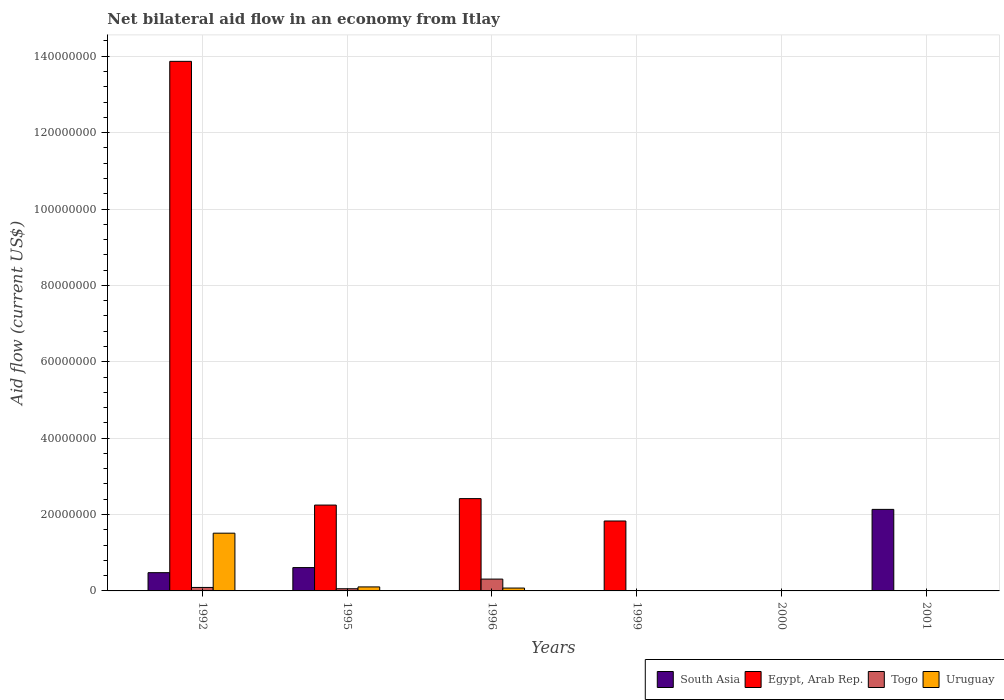Are the number of bars on each tick of the X-axis equal?
Give a very brief answer. No. How many bars are there on the 4th tick from the right?
Your response must be concise. 3. What is the label of the 3rd group of bars from the left?
Give a very brief answer. 1996. In how many cases, is the number of bars for a given year not equal to the number of legend labels?
Provide a short and direct response. 4. What is the net bilateral aid flow in Uruguay in 1992?
Provide a short and direct response. 1.51e+07. Across all years, what is the maximum net bilateral aid flow in Uruguay?
Offer a terse response. 1.51e+07. What is the total net bilateral aid flow in South Asia in the graph?
Provide a succinct answer. 3.22e+07. What is the difference between the net bilateral aid flow in Togo in 1996 and that in 2001?
Your answer should be compact. 3.02e+06. What is the difference between the net bilateral aid flow in Togo in 2000 and the net bilateral aid flow in South Asia in 1999?
Your answer should be compact. 10000. What is the average net bilateral aid flow in Uruguay per year?
Provide a short and direct response. 2.82e+06. In the year 1992, what is the difference between the net bilateral aid flow in Uruguay and net bilateral aid flow in Togo?
Your answer should be very brief. 1.42e+07. What is the ratio of the net bilateral aid flow in Uruguay in 1992 to that in 1996?
Keep it short and to the point. 20.16. Is the net bilateral aid flow in Togo in 1992 less than that in 2001?
Keep it short and to the point. No. What is the difference between the highest and the second highest net bilateral aid flow in Togo?
Your answer should be very brief. 2.19e+06. What is the difference between the highest and the lowest net bilateral aid flow in Egypt, Arab Rep.?
Make the answer very short. 1.39e+08. Is the sum of the net bilateral aid flow in Togo in 1995 and 1999 greater than the maximum net bilateral aid flow in Egypt, Arab Rep. across all years?
Provide a succinct answer. No. Are all the bars in the graph horizontal?
Provide a short and direct response. No. How many years are there in the graph?
Your answer should be very brief. 6. How many legend labels are there?
Make the answer very short. 4. How are the legend labels stacked?
Your answer should be compact. Horizontal. What is the title of the graph?
Provide a short and direct response. Net bilateral aid flow in an economy from Itlay. What is the label or title of the Y-axis?
Offer a terse response. Aid flow (current US$). What is the Aid flow (current US$) of South Asia in 1992?
Your answer should be compact. 4.78e+06. What is the Aid flow (current US$) of Egypt, Arab Rep. in 1992?
Provide a succinct answer. 1.39e+08. What is the Aid flow (current US$) in Togo in 1992?
Provide a succinct answer. 9.10e+05. What is the Aid flow (current US$) in Uruguay in 1992?
Make the answer very short. 1.51e+07. What is the Aid flow (current US$) in South Asia in 1995?
Provide a short and direct response. 6.11e+06. What is the Aid flow (current US$) of Egypt, Arab Rep. in 1995?
Offer a terse response. 2.25e+07. What is the Aid flow (current US$) in Togo in 1995?
Keep it short and to the point. 5.70e+05. What is the Aid flow (current US$) of Uruguay in 1995?
Make the answer very short. 1.05e+06. What is the Aid flow (current US$) in South Asia in 1996?
Provide a succinct answer. 0. What is the Aid flow (current US$) of Egypt, Arab Rep. in 1996?
Keep it short and to the point. 2.42e+07. What is the Aid flow (current US$) in Togo in 1996?
Ensure brevity in your answer.  3.10e+06. What is the Aid flow (current US$) in Uruguay in 1996?
Ensure brevity in your answer.  7.50e+05. What is the Aid flow (current US$) in South Asia in 1999?
Your answer should be very brief. 0. What is the Aid flow (current US$) in Egypt, Arab Rep. in 1999?
Ensure brevity in your answer.  1.83e+07. What is the Aid flow (current US$) in South Asia in 2000?
Keep it short and to the point. 0. What is the Aid flow (current US$) of Egypt, Arab Rep. in 2000?
Make the answer very short. 0. What is the Aid flow (current US$) of Togo in 2000?
Make the answer very short. 10000. What is the Aid flow (current US$) in Uruguay in 2000?
Provide a succinct answer. 0. What is the Aid flow (current US$) of South Asia in 2001?
Your response must be concise. 2.14e+07. What is the Aid flow (current US$) of Togo in 2001?
Your response must be concise. 8.00e+04. What is the Aid flow (current US$) of Uruguay in 2001?
Give a very brief answer. 0. Across all years, what is the maximum Aid flow (current US$) of South Asia?
Make the answer very short. 2.14e+07. Across all years, what is the maximum Aid flow (current US$) of Egypt, Arab Rep.?
Make the answer very short. 1.39e+08. Across all years, what is the maximum Aid flow (current US$) of Togo?
Offer a very short reply. 3.10e+06. Across all years, what is the maximum Aid flow (current US$) in Uruguay?
Make the answer very short. 1.51e+07. Across all years, what is the minimum Aid flow (current US$) of Egypt, Arab Rep.?
Give a very brief answer. 0. Across all years, what is the minimum Aid flow (current US$) of Togo?
Keep it short and to the point. 10000. Across all years, what is the minimum Aid flow (current US$) of Uruguay?
Your answer should be very brief. 0. What is the total Aid flow (current US$) in South Asia in the graph?
Your answer should be very brief. 3.22e+07. What is the total Aid flow (current US$) of Egypt, Arab Rep. in the graph?
Provide a short and direct response. 2.04e+08. What is the total Aid flow (current US$) of Togo in the graph?
Make the answer very short. 4.68e+06. What is the total Aid flow (current US$) of Uruguay in the graph?
Your answer should be compact. 1.69e+07. What is the difference between the Aid flow (current US$) in South Asia in 1992 and that in 1995?
Your answer should be compact. -1.33e+06. What is the difference between the Aid flow (current US$) in Egypt, Arab Rep. in 1992 and that in 1995?
Your answer should be compact. 1.16e+08. What is the difference between the Aid flow (current US$) in Uruguay in 1992 and that in 1995?
Give a very brief answer. 1.41e+07. What is the difference between the Aid flow (current US$) of Egypt, Arab Rep. in 1992 and that in 1996?
Ensure brevity in your answer.  1.14e+08. What is the difference between the Aid flow (current US$) in Togo in 1992 and that in 1996?
Your response must be concise. -2.19e+06. What is the difference between the Aid flow (current US$) in Uruguay in 1992 and that in 1996?
Offer a terse response. 1.44e+07. What is the difference between the Aid flow (current US$) in Egypt, Arab Rep. in 1992 and that in 1999?
Keep it short and to the point. 1.20e+08. What is the difference between the Aid flow (current US$) of Togo in 1992 and that in 2000?
Offer a terse response. 9.00e+05. What is the difference between the Aid flow (current US$) in South Asia in 1992 and that in 2001?
Your answer should be very brief. -1.66e+07. What is the difference between the Aid flow (current US$) of Togo in 1992 and that in 2001?
Provide a short and direct response. 8.30e+05. What is the difference between the Aid flow (current US$) in Egypt, Arab Rep. in 1995 and that in 1996?
Your response must be concise. -1.69e+06. What is the difference between the Aid flow (current US$) of Togo in 1995 and that in 1996?
Your answer should be compact. -2.53e+06. What is the difference between the Aid flow (current US$) in Egypt, Arab Rep. in 1995 and that in 1999?
Ensure brevity in your answer.  4.17e+06. What is the difference between the Aid flow (current US$) in Togo in 1995 and that in 1999?
Your response must be concise. 5.60e+05. What is the difference between the Aid flow (current US$) in Togo in 1995 and that in 2000?
Offer a terse response. 5.60e+05. What is the difference between the Aid flow (current US$) of South Asia in 1995 and that in 2001?
Keep it short and to the point. -1.52e+07. What is the difference between the Aid flow (current US$) in Egypt, Arab Rep. in 1996 and that in 1999?
Keep it short and to the point. 5.86e+06. What is the difference between the Aid flow (current US$) of Togo in 1996 and that in 1999?
Your response must be concise. 3.09e+06. What is the difference between the Aid flow (current US$) of Togo in 1996 and that in 2000?
Give a very brief answer. 3.09e+06. What is the difference between the Aid flow (current US$) of Togo in 1996 and that in 2001?
Provide a succinct answer. 3.02e+06. What is the difference between the Aid flow (current US$) in Togo in 1999 and that in 2000?
Provide a short and direct response. 0. What is the difference between the Aid flow (current US$) of Togo in 2000 and that in 2001?
Your answer should be compact. -7.00e+04. What is the difference between the Aid flow (current US$) in South Asia in 1992 and the Aid flow (current US$) in Egypt, Arab Rep. in 1995?
Provide a succinct answer. -1.77e+07. What is the difference between the Aid flow (current US$) of South Asia in 1992 and the Aid flow (current US$) of Togo in 1995?
Keep it short and to the point. 4.21e+06. What is the difference between the Aid flow (current US$) in South Asia in 1992 and the Aid flow (current US$) in Uruguay in 1995?
Ensure brevity in your answer.  3.73e+06. What is the difference between the Aid flow (current US$) in Egypt, Arab Rep. in 1992 and the Aid flow (current US$) in Togo in 1995?
Offer a very short reply. 1.38e+08. What is the difference between the Aid flow (current US$) in Egypt, Arab Rep. in 1992 and the Aid flow (current US$) in Uruguay in 1995?
Offer a very short reply. 1.38e+08. What is the difference between the Aid flow (current US$) in Togo in 1992 and the Aid flow (current US$) in Uruguay in 1995?
Provide a short and direct response. -1.40e+05. What is the difference between the Aid flow (current US$) of South Asia in 1992 and the Aid flow (current US$) of Egypt, Arab Rep. in 1996?
Provide a short and direct response. -1.94e+07. What is the difference between the Aid flow (current US$) in South Asia in 1992 and the Aid flow (current US$) in Togo in 1996?
Your answer should be very brief. 1.68e+06. What is the difference between the Aid flow (current US$) in South Asia in 1992 and the Aid flow (current US$) in Uruguay in 1996?
Ensure brevity in your answer.  4.03e+06. What is the difference between the Aid flow (current US$) in Egypt, Arab Rep. in 1992 and the Aid flow (current US$) in Togo in 1996?
Make the answer very short. 1.36e+08. What is the difference between the Aid flow (current US$) in Egypt, Arab Rep. in 1992 and the Aid flow (current US$) in Uruguay in 1996?
Provide a short and direct response. 1.38e+08. What is the difference between the Aid flow (current US$) in South Asia in 1992 and the Aid flow (current US$) in Egypt, Arab Rep. in 1999?
Give a very brief answer. -1.35e+07. What is the difference between the Aid flow (current US$) in South Asia in 1992 and the Aid flow (current US$) in Togo in 1999?
Offer a terse response. 4.77e+06. What is the difference between the Aid flow (current US$) of Egypt, Arab Rep. in 1992 and the Aid flow (current US$) of Togo in 1999?
Ensure brevity in your answer.  1.39e+08. What is the difference between the Aid flow (current US$) in South Asia in 1992 and the Aid flow (current US$) in Togo in 2000?
Keep it short and to the point. 4.77e+06. What is the difference between the Aid flow (current US$) in Egypt, Arab Rep. in 1992 and the Aid flow (current US$) in Togo in 2000?
Provide a short and direct response. 1.39e+08. What is the difference between the Aid flow (current US$) in South Asia in 1992 and the Aid flow (current US$) in Togo in 2001?
Your answer should be very brief. 4.70e+06. What is the difference between the Aid flow (current US$) of Egypt, Arab Rep. in 1992 and the Aid flow (current US$) of Togo in 2001?
Provide a short and direct response. 1.39e+08. What is the difference between the Aid flow (current US$) in South Asia in 1995 and the Aid flow (current US$) in Egypt, Arab Rep. in 1996?
Provide a short and direct response. -1.81e+07. What is the difference between the Aid flow (current US$) in South Asia in 1995 and the Aid flow (current US$) in Togo in 1996?
Provide a short and direct response. 3.01e+06. What is the difference between the Aid flow (current US$) in South Asia in 1995 and the Aid flow (current US$) in Uruguay in 1996?
Ensure brevity in your answer.  5.36e+06. What is the difference between the Aid flow (current US$) of Egypt, Arab Rep. in 1995 and the Aid flow (current US$) of Togo in 1996?
Provide a succinct answer. 1.94e+07. What is the difference between the Aid flow (current US$) of Egypt, Arab Rep. in 1995 and the Aid flow (current US$) of Uruguay in 1996?
Provide a succinct answer. 2.17e+07. What is the difference between the Aid flow (current US$) of Togo in 1995 and the Aid flow (current US$) of Uruguay in 1996?
Make the answer very short. -1.80e+05. What is the difference between the Aid flow (current US$) in South Asia in 1995 and the Aid flow (current US$) in Egypt, Arab Rep. in 1999?
Provide a short and direct response. -1.22e+07. What is the difference between the Aid flow (current US$) of South Asia in 1995 and the Aid flow (current US$) of Togo in 1999?
Offer a very short reply. 6.10e+06. What is the difference between the Aid flow (current US$) of Egypt, Arab Rep. in 1995 and the Aid flow (current US$) of Togo in 1999?
Your answer should be very brief. 2.25e+07. What is the difference between the Aid flow (current US$) in South Asia in 1995 and the Aid flow (current US$) in Togo in 2000?
Keep it short and to the point. 6.10e+06. What is the difference between the Aid flow (current US$) in Egypt, Arab Rep. in 1995 and the Aid flow (current US$) in Togo in 2000?
Ensure brevity in your answer.  2.25e+07. What is the difference between the Aid flow (current US$) in South Asia in 1995 and the Aid flow (current US$) in Togo in 2001?
Your answer should be compact. 6.03e+06. What is the difference between the Aid flow (current US$) in Egypt, Arab Rep. in 1995 and the Aid flow (current US$) in Togo in 2001?
Offer a very short reply. 2.24e+07. What is the difference between the Aid flow (current US$) of Egypt, Arab Rep. in 1996 and the Aid flow (current US$) of Togo in 1999?
Your answer should be compact. 2.42e+07. What is the difference between the Aid flow (current US$) of Egypt, Arab Rep. in 1996 and the Aid flow (current US$) of Togo in 2000?
Ensure brevity in your answer.  2.42e+07. What is the difference between the Aid flow (current US$) in Egypt, Arab Rep. in 1996 and the Aid flow (current US$) in Togo in 2001?
Keep it short and to the point. 2.41e+07. What is the difference between the Aid flow (current US$) of Egypt, Arab Rep. in 1999 and the Aid flow (current US$) of Togo in 2000?
Your answer should be compact. 1.83e+07. What is the difference between the Aid flow (current US$) of Egypt, Arab Rep. in 1999 and the Aid flow (current US$) of Togo in 2001?
Your answer should be very brief. 1.82e+07. What is the average Aid flow (current US$) in South Asia per year?
Keep it short and to the point. 5.37e+06. What is the average Aid flow (current US$) of Egypt, Arab Rep. per year?
Make the answer very short. 3.39e+07. What is the average Aid flow (current US$) in Togo per year?
Give a very brief answer. 7.80e+05. What is the average Aid flow (current US$) of Uruguay per year?
Make the answer very short. 2.82e+06. In the year 1992, what is the difference between the Aid flow (current US$) of South Asia and Aid flow (current US$) of Egypt, Arab Rep.?
Offer a terse response. -1.34e+08. In the year 1992, what is the difference between the Aid flow (current US$) of South Asia and Aid flow (current US$) of Togo?
Offer a terse response. 3.87e+06. In the year 1992, what is the difference between the Aid flow (current US$) in South Asia and Aid flow (current US$) in Uruguay?
Offer a very short reply. -1.03e+07. In the year 1992, what is the difference between the Aid flow (current US$) in Egypt, Arab Rep. and Aid flow (current US$) in Togo?
Keep it short and to the point. 1.38e+08. In the year 1992, what is the difference between the Aid flow (current US$) in Egypt, Arab Rep. and Aid flow (current US$) in Uruguay?
Your answer should be compact. 1.24e+08. In the year 1992, what is the difference between the Aid flow (current US$) in Togo and Aid flow (current US$) in Uruguay?
Give a very brief answer. -1.42e+07. In the year 1995, what is the difference between the Aid flow (current US$) in South Asia and Aid flow (current US$) in Egypt, Arab Rep.?
Ensure brevity in your answer.  -1.64e+07. In the year 1995, what is the difference between the Aid flow (current US$) in South Asia and Aid flow (current US$) in Togo?
Your response must be concise. 5.54e+06. In the year 1995, what is the difference between the Aid flow (current US$) of South Asia and Aid flow (current US$) of Uruguay?
Keep it short and to the point. 5.06e+06. In the year 1995, what is the difference between the Aid flow (current US$) in Egypt, Arab Rep. and Aid flow (current US$) in Togo?
Offer a terse response. 2.19e+07. In the year 1995, what is the difference between the Aid flow (current US$) of Egypt, Arab Rep. and Aid flow (current US$) of Uruguay?
Keep it short and to the point. 2.14e+07. In the year 1995, what is the difference between the Aid flow (current US$) of Togo and Aid flow (current US$) of Uruguay?
Give a very brief answer. -4.80e+05. In the year 1996, what is the difference between the Aid flow (current US$) in Egypt, Arab Rep. and Aid flow (current US$) in Togo?
Your response must be concise. 2.11e+07. In the year 1996, what is the difference between the Aid flow (current US$) of Egypt, Arab Rep. and Aid flow (current US$) of Uruguay?
Give a very brief answer. 2.34e+07. In the year 1996, what is the difference between the Aid flow (current US$) in Togo and Aid flow (current US$) in Uruguay?
Your answer should be very brief. 2.35e+06. In the year 1999, what is the difference between the Aid flow (current US$) in Egypt, Arab Rep. and Aid flow (current US$) in Togo?
Your answer should be very brief. 1.83e+07. In the year 2001, what is the difference between the Aid flow (current US$) of South Asia and Aid flow (current US$) of Togo?
Keep it short and to the point. 2.13e+07. What is the ratio of the Aid flow (current US$) of South Asia in 1992 to that in 1995?
Provide a short and direct response. 0.78. What is the ratio of the Aid flow (current US$) in Egypt, Arab Rep. in 1992 to that in 1995?
Make the answer very short. 6.17. What is the ratio of the Aid flow (current US$) in Togo in 1992 to that in 1995?
Ensure brevity in your answer.  1.6. What is the ratio of the Aid flow (current US$) of Uruguay in 1992 to that in 1995?
Offer a terse response. 14.4. What is the ratio of the Aid flow (current US$) of Egypt, Arab Rep. in 1992 to that in 1996?
Make the answer very short. 5.74. What is the ratio of the Aid flow (current US$) in Togo in 1992 to that in 1996?
Your response must be concise. 0.29. What is the ratio of the Aid flow (current US$) of Uruguay in 1992 to that in 1996?
Keep it short and to the point. 20.16. What is the ratio of the Aid flow (current US$) of Egypt, Arab Rep. in 1992 to that in 1999?
Your response must be concise. 7.57. What is the ratio of the Aid flow (current US$) in Togo in 1992 to that in 1999?
Provide a succinct answer. 91. What is the ratio of the Aid flow (current US$) in Togo in 1992 to that in 2000?
Keep it short and to the point. 91. What is the ratio of the Aid flow (current US$) of South Asia in 1992 to that in 2001?
Give a very brief answer. 0.22. What is the ratio of the Aid flow (current US$) of Togo in 1992 to that in 2001?
Provide a short and direct response. 11.38. What is the ratio of the Aid flow (current US$) in Egypt, Arab Rep. in 1995 to that in 1996?
Ensure brevity in your answer.  0.93. What is the ratio of the Aid flow (current US$) of Togo in 1995 to that in 1996?
Provide a succinct answer. 0.18. What is the ratio of the Aid flow (current US$) of Egypt, Arab Rep. in 1995 to that in 1999?
Your response must be concise. 1.23. What is the ratio of the Aid flow (current US$) in South Asia in 1995 to that in 2001?
Your answer should be very brief. 0.29. What is the ratio of the Aid flow (current US$) in Togo in 1995 to that in 2001?
Your answer should be compact. 7.12. What is the ratio of the Aid flow (current US$) of Egypt, Arab Rep. in 1996 to that in 1999?
Offer a very short reply. 1.32. What is the ratio of the Aid flow (current US$) of Togo in 1996 to that in 1999?
Make the answer very short. 310. What is the ratio of the Aid flow (current US$) of Togo in 1996 to that in 2000?
Offer a very short reply. 310. What is the ratio of the Aid flow (current US$) of Togo in 1996 to that in 2001?
Provide a succinct answer. 38.75. What is the ratio of the Aid flow (current US$) of Togo in 1999 to that in 2000?
Provide a short and direct response. 1. What is the ratio of the Aid flow (current US$) of Togo in 1999 to that in 2001?
Offer a very short reply. 0.12. What is the ratio of the Aid flow (current US$) in Togo in 2000 to that in 2001?
Your answer should be compact. 0.12. What is the difference between the highest and the second highest Aid flow (current US$) in South Asia?
Offer a very short reply. 1.52e+07. What is the difference between the highest and the second highest Aid flow (current US$) in Egypt, Arab Rep.?
Your response must be concise. 1.14e+08. What is the difference between the highest and the second highest Aid flow (current US$) of Togo?
Provide a succinct answer. 2.19e+06. What is the difference between the highest and the second highest Aid flow (current US$) in Uruguay?
Ensure brevity in your answer.  1.41e+07. What is the difference between the highest and the lowest Aid flow (current US$) of South Asia?
Your response must be concise. 2.14e+07. What is the difference between the highest and the lowest Aid flow (current US$) in Egypt, Arab Rep.?
Provide a succinct answer. 1.39e+08. What is the difference between the highest and the lowest Aid flow (current US$) of Togo?
Your response must be concise. 3.09e+06. What is the difference between the highest and the lowest Aid flow (current US$) in Uruguay?
Ensure brevity in your answer.  1.51e+07. 